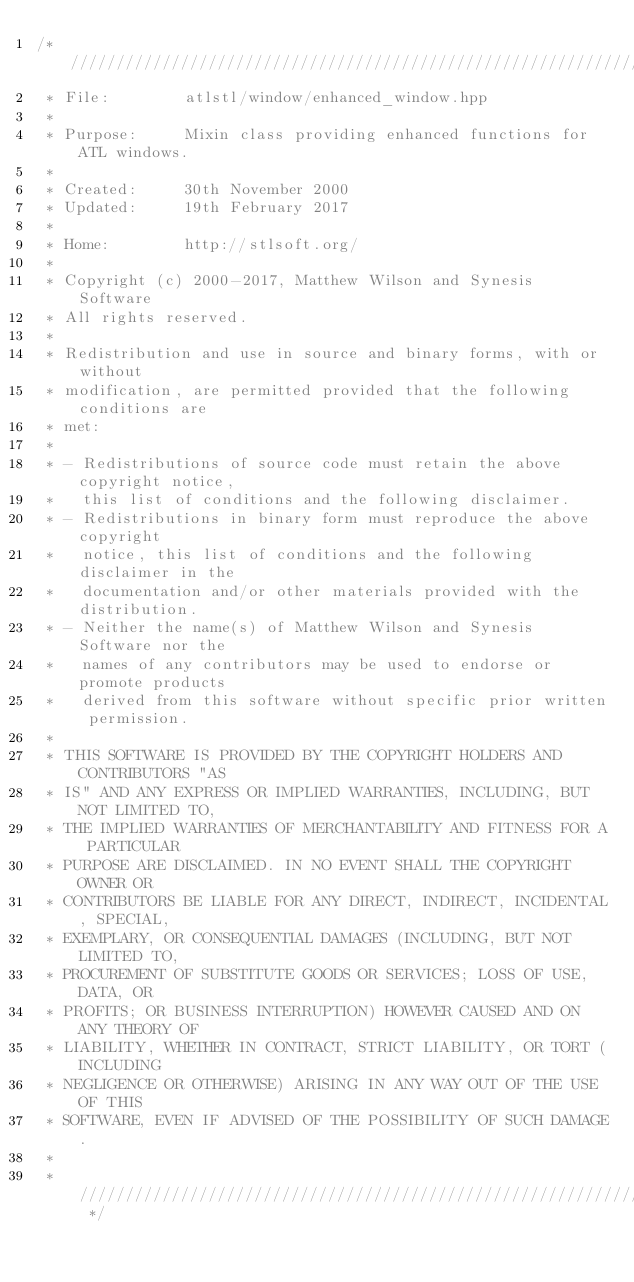Convert code to text. <code><loc_0><loc_0><loc_500><loc_500><_C++_>/* /////////////////////////////////////////////////////////////////////////
 * File:        atlstl/window/enhanced_window.hpp
 *
 * Purpose:     Mixin class providing enhanced functions for ATL windows.
 *
 * Created:     30th November 2000
 * Updated:     19th February 2017
 *
 * Home:        http://stlsoft.org/
 *
 * Copyright (c) 2000-2017, Matthew Wilson and Synesis Software
 * All rights reserved.
 *
 * Redistribution and use in source and binary forms, with or without
 * modification, are permitted provided that the following conditions are
 * met:
 *
 * - Redistributions of source code must retain the above copyright notice,
 *   this list of conditions and the following disclaimer.
 * - Redistributions in binary form must reproduce the above copyright
 *   notice, this list of conditions and the following disclaimer in the
 *   documentation and/or other materials provided with the distribution.
 * - Neither the name(s) of Matthew Wilson and Synesis Software nor the
 *   names of any contributors may be used to endorse or promote products
 *   derived from this software without specific prior written permission.
 *
 * THIS SOFTWARE IS PROVIDED BY THE COPYRIGHT HOLDERS AND CONTRIBUTORS "AS
 * IS" AND ANY EXPRESS OR IMPLIED WARRANTIES, INCLUDING, BUT NOT LIMITED TO,
 * THE IMPLIED WARRANTIES OF MERCHANTABILITY AND FITNESS FOR A PARTICULAR
 * PURPOSE ARE DISCLAIMED. IN NO EVENT SHALL THE COPYRIGHT OWNER OR
 * CONTRIBUTORS BE LIABLE FOR ANY DIRECT, INDIRECT, INCIDENTAL, SPECIAL,
 * EXEMPLARY, OR CONSEQUENTIAL DAMAGES (INCLUDING, BUT NOT LIMITED TO,
 * PROCUREMENT OF SUBSTITUTE GOODS OR SERVICES; LOSS OF USE, DATA, OR
 * PROFITS; OR BUSINESS INTERRUPTION) HOWEVER CAUSED AND ON ANY THEORY OF
 * LIABILITY, WHETHER IN CONTRACT, STRICT LIABILITY, OR TORT (INCLUDING
 * NEGLIGENCE OR OTHERWISE) ARISING IN ANY WAY OUT OF THE USE OF THIS
 * SOFTWARE, EVEN IF ADVISED OF THE POSSIBILITY OF SUCH DAMAGE.
 *
 * ////////////////////////////////////////////////////////////////////// */

</code> 